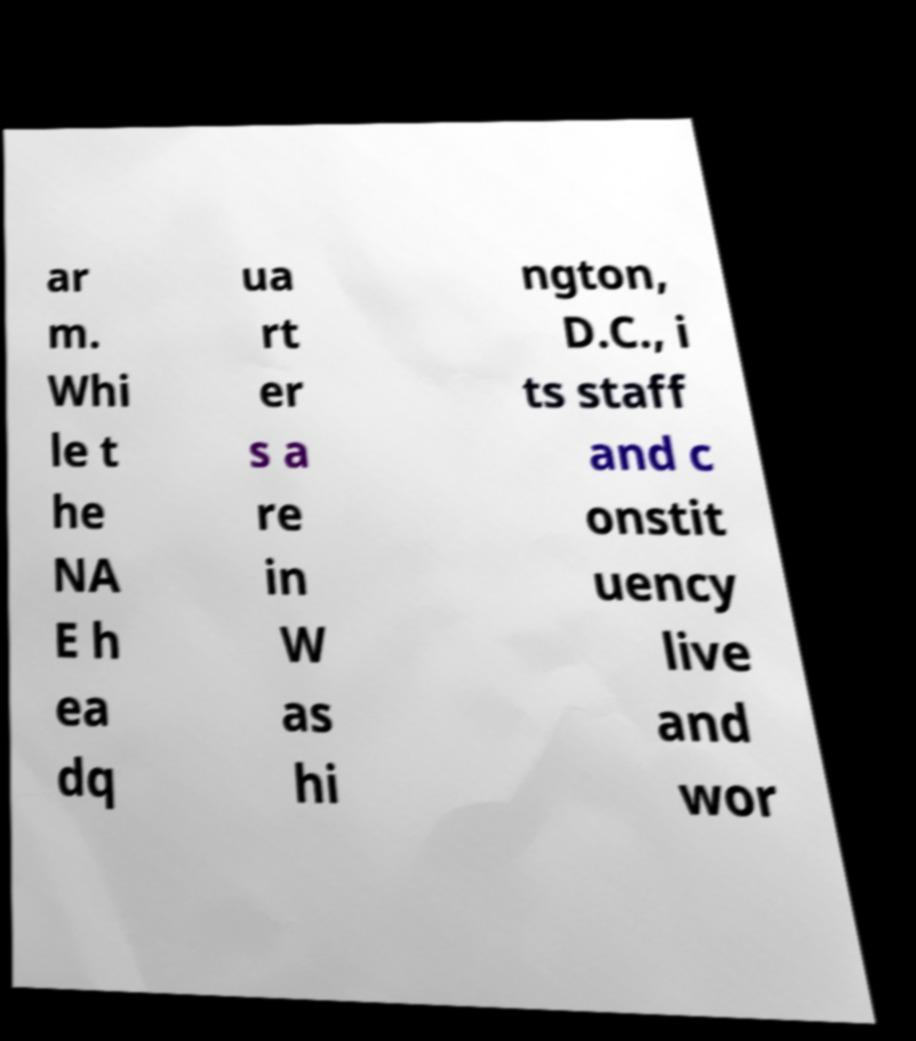What messages or text are displayed in this image? I need them in a readable, typed format. ar m. Whi le t he NA E h ea dq ua rt er s a re in W as hi ngton, D.C., i ts staff and c onstit uency live and wor 